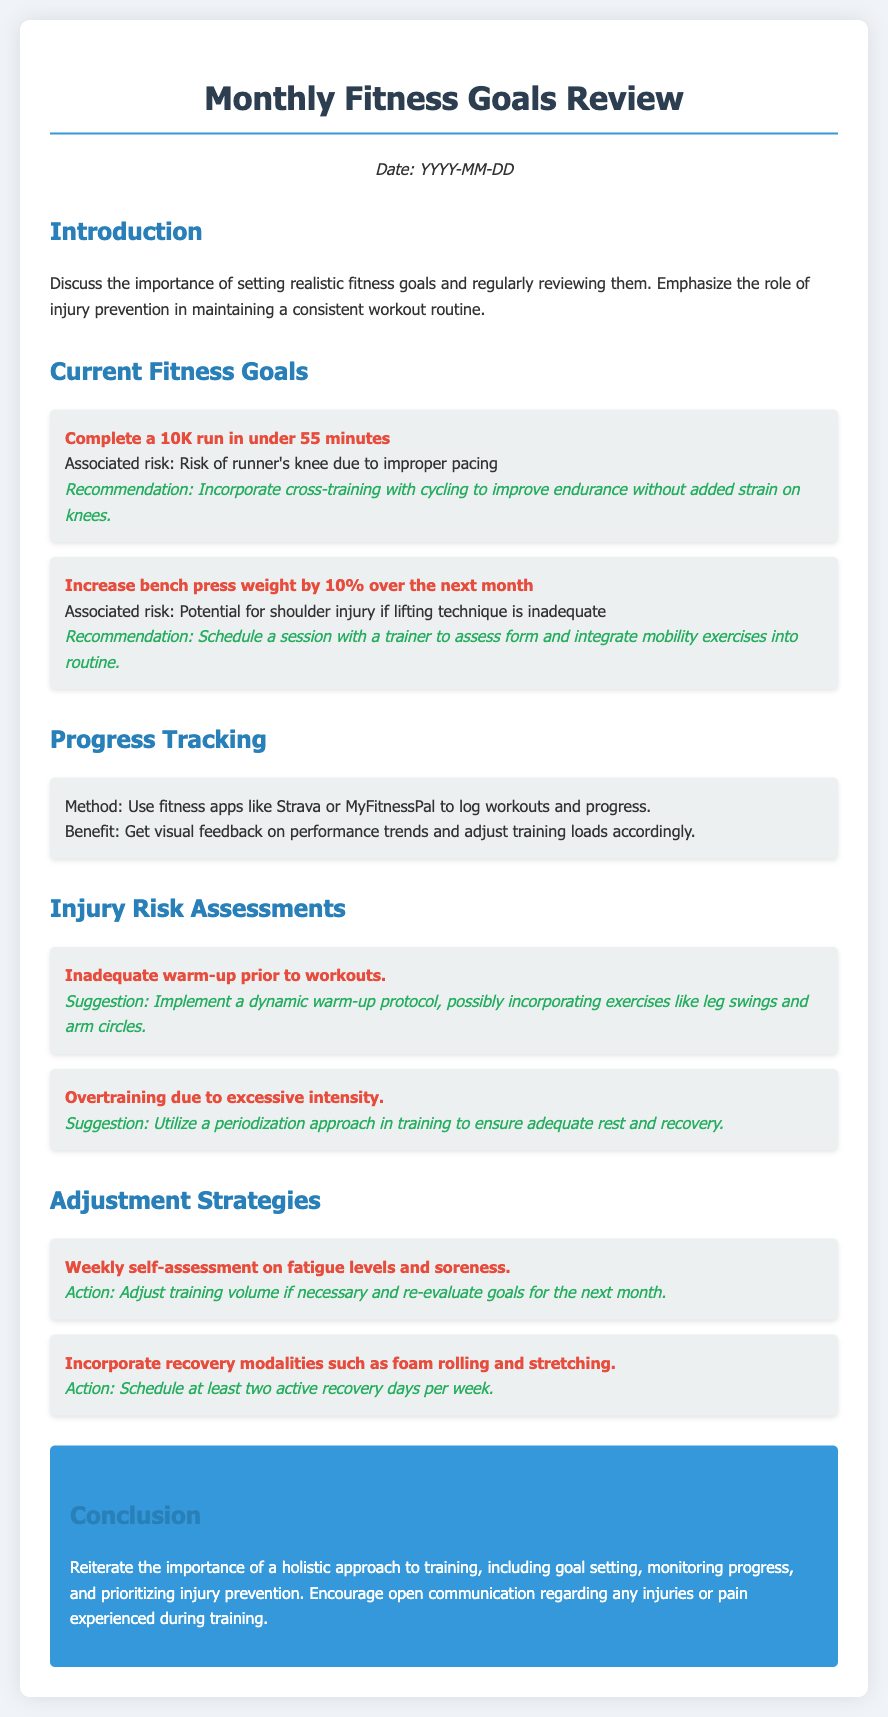What is the date of the review? The date of the review is mentioned at the beginning of the document as "YYYY-MM-DD."
Answer: YYYY-MM-DD What is the first fitness goal listed? The first fitness goal listed is "Complete a 10K run in under 55 minutes."
Answer: Complete a 10K run in under 55 minutes What is the associated risk for the 10K goal? The associated risk for the 10K goal is "Risk of runner's knee due to improper pacing."
Answer: Risk of runner's knee due to improper pacing What is one recommendation for improving bench press weight? One recommendation is to "Schedule a session with a trainer to assess form and integrate mobility exercises into routine."
Answer: Schedule a session with a trainer to assess form and integrate mobility exercises into routine What method is suggested for progress tracking? The document suggests using "fitness apps like Strava or MyFitnessPal to log workouts and progress."
Answer: fitness apps like Strava or MyFitnessPal to log workouts and progress What is the suggestion for inadequate warm-up? The suggestion is to "Implement a dynamic warm-up protocol, possibly incorporating exercises like leg swings and arm circles."
Answer: Implement a dynamic warm-up protocol, possibly incorporating exercises like leg swings and arm circles How often should active recovery days be scheduled? The document states to "Schedule at least two active recovery days per week."
Answer: Schedule at least two active recovery days per week What is the color of the conclusion box? The color of the conclusion box is "blue."
Answer: blue 